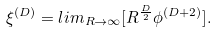Convert formula to latex. <formula><loc_0><loc_0><loc_500><loc_500>\xi ^ { ( D ) } = l i m _ { R \rightarrow \infty } [ R ^ { \frac { D } { 2 } } \phi ^ { ( D + 2 ) } ] .</formula> 